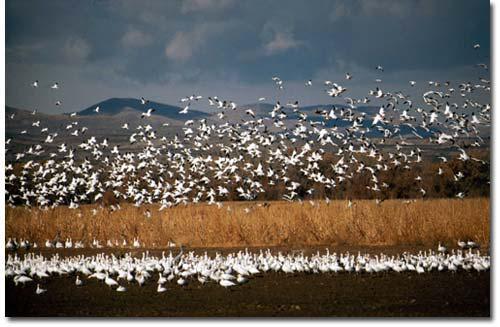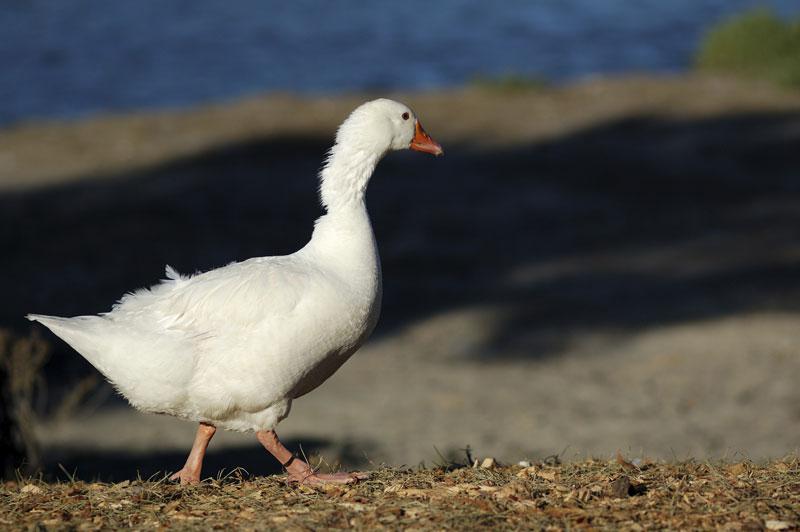The first image is the image on the left, the second image is the image on the right. For the images displayed, is the sentence "There are less than five birds in one of the pictures." factually correct? Answer yes or no. Yes. The first image is the image on the left, the second image is the image on the right. For the images shown, is this caption "An image contains no more than five fowl." true? Answer yes or no. Yes. 